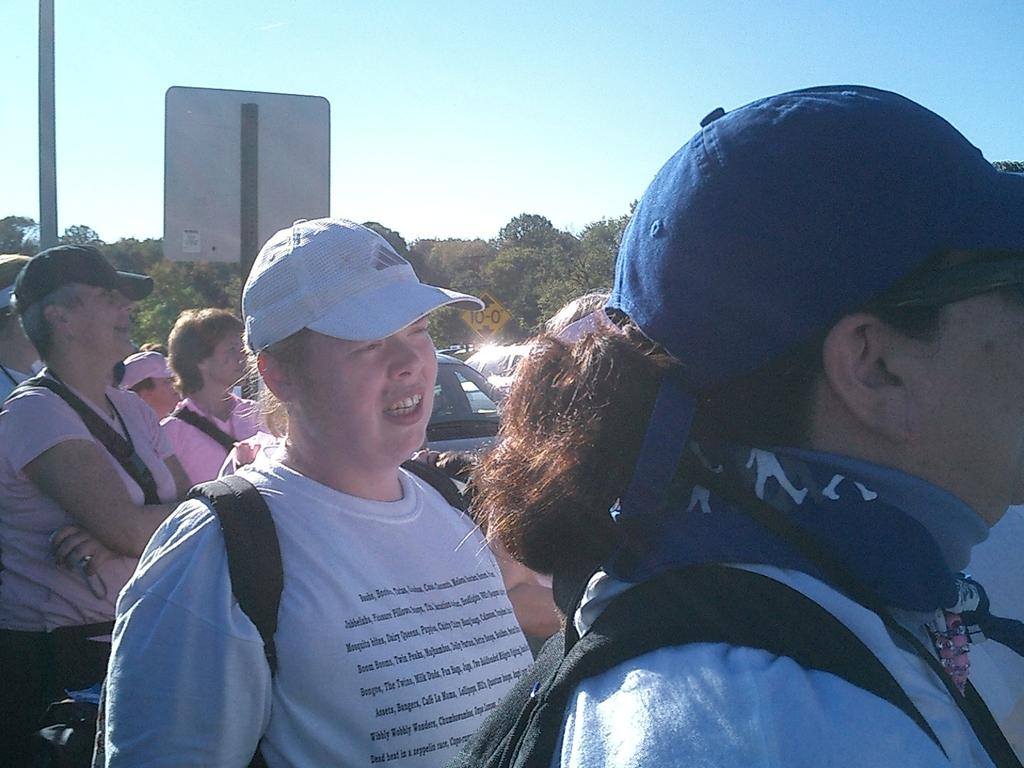How many people are in the image? There is a group of people in the image, but the exact number cannot be determined from the provided facts. What else can be seen in the image besides the group of people? There are vehicles, a pole, signboards, a group of trees, and the sky visible in the image. What might the vehicles be used for? The vehicles in the image could be used for transportation. What can be found on the pole in the image? The facts do not specify what is on the pole, so we cannot determine that information. What type of screw is holding the window in place in the image? There is no window present in the image, so there is no screw holding it in place. 